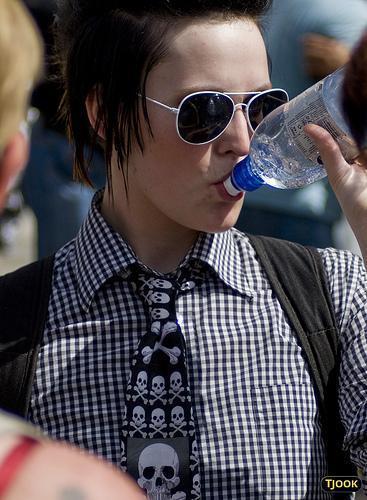How many people wearing glasses?
Give a very brief answer. 1. 